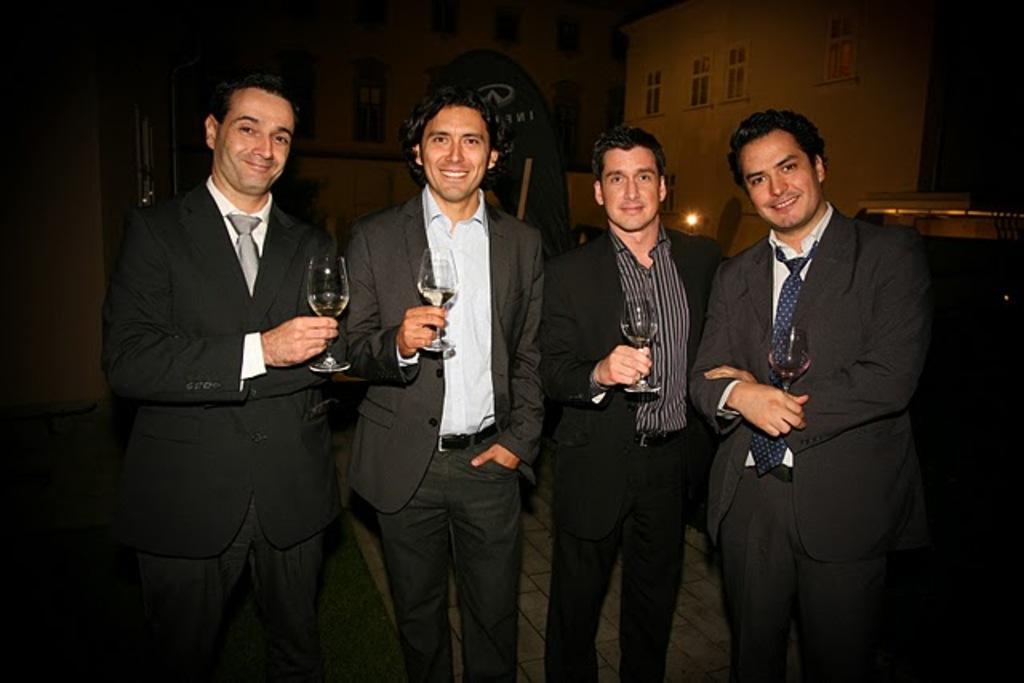Describe this image in one or two sentences. In this image we can see some persons and glasses. In the background of the image there are buildings, light and other objects. 